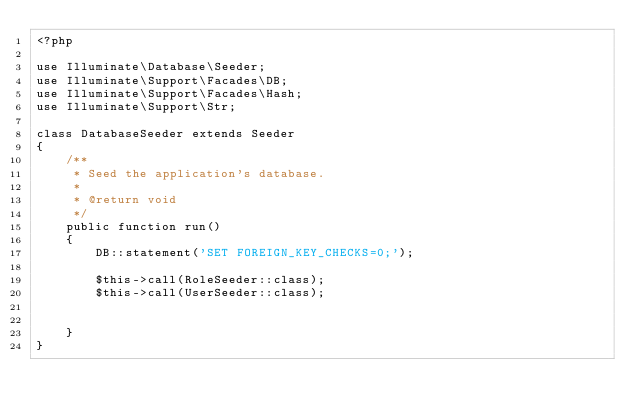Convert code to text. <code><loc_0><loc_0><loc_500><loc_500><_PHP_><?php

use Illuminate\Database\Seeder;
use Illuminate\Support\Facades\DB;
use Illuminate\Support\Facades\Hash;
use Illuminate\Support\Str;

class DatabaseSeeder extends Seeder
{
    /**
     * Seed the application's database.
     *
     * @return void
     */
    public function run()
    {
        DB::statement('SET FOREIGN_KEY_CHECKS=0;');

        $this->call(RoleSeeder::class);
        $this->call(UserSeeder::class);


    }
}
</code> 